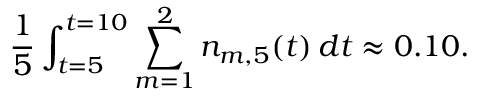<formula> <loc_0><loc_0><loc_500><loc_500>\frac { 1 } { 5 } \int _ { t = 5 } ^ { t = 1 0 } \sum _ { m = 1 } ^ { 2 } n _ { m , 5 } ( t ) \, d t \approx 0 . 1 0 .</formula> 